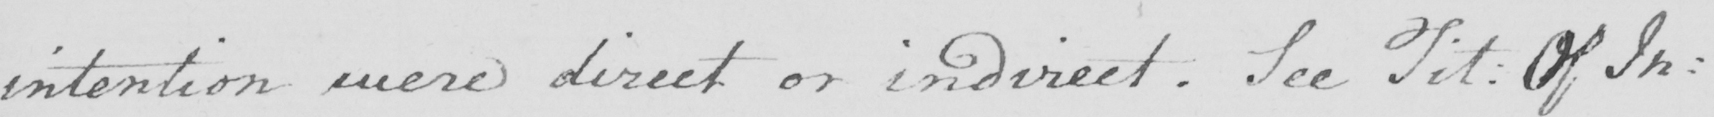What does this handwritten line say? intention were direct or indirect . See Tit :  Of In : 